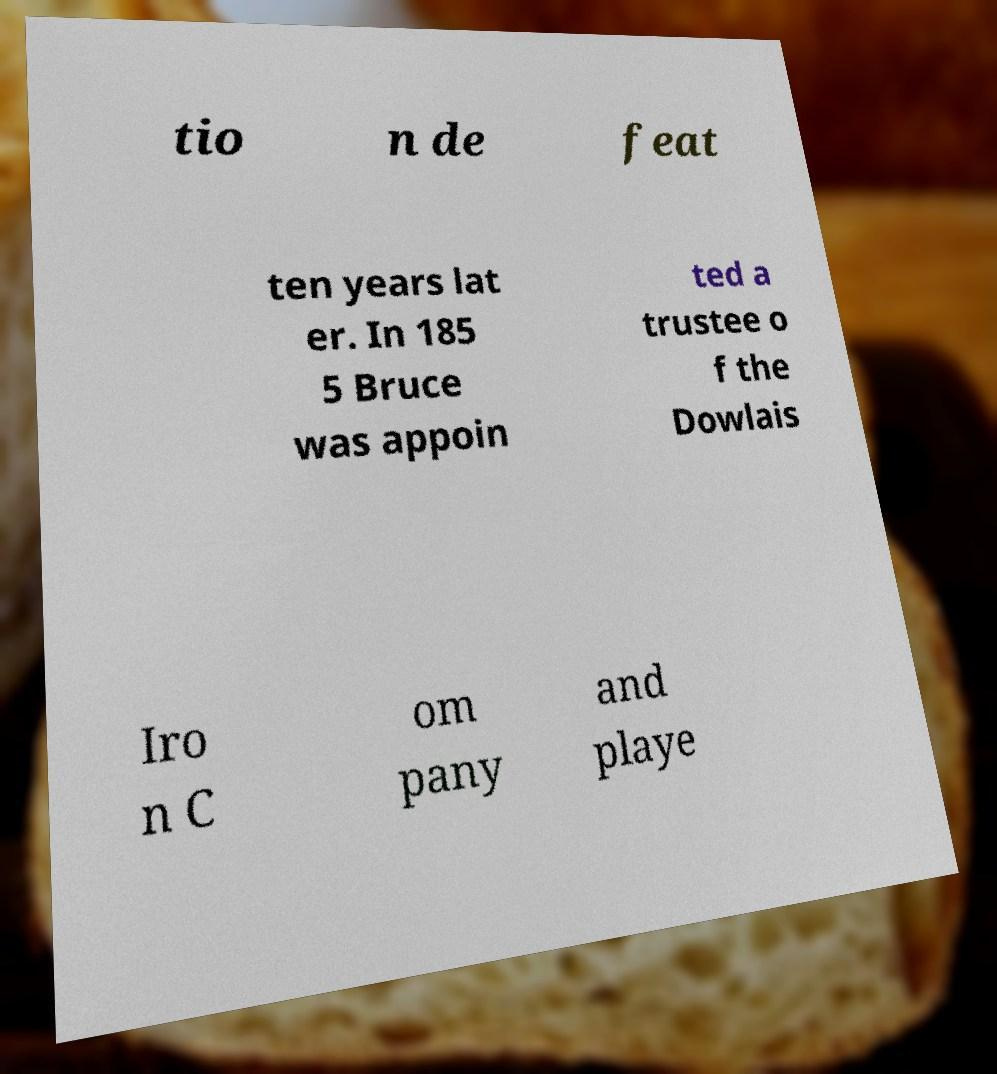What messages or text are displayed in this image? I need them in a readable, typed format. tio n de feat ten years lat er. In 185 5 Bruce was appoin ted a trustee o f the Dowlais Iro n C om pany and playe 